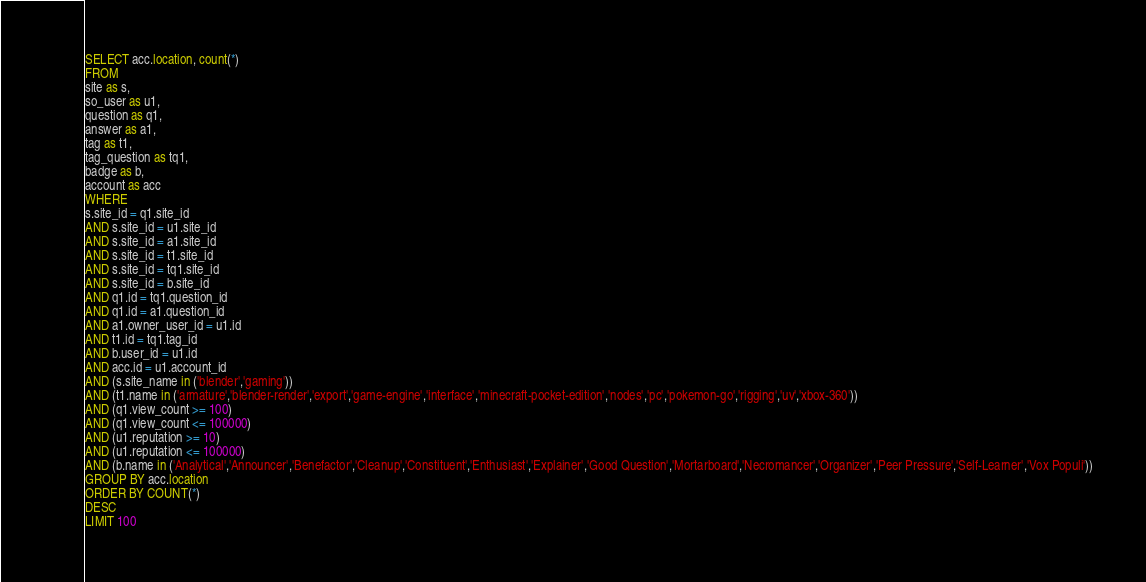Convert code to text. <code><loc_0><loc_0><loc_500><loc_500><_SQL_>SELECT acc.location, count(*)
FROM
site as s,
so_user as u1,
question as q1,
answer as a1,
tag as t1,
tag_question as tq1,
badge as b,
account as acc
WHERE
s.site_id = q1.site_id
AND s.site_id = u1.site_id
AND s.site_id = a1.site_id
AND s.site_id = t1.site_id
AND s.site_id = tq1.site_id
AND s.site_id = b.site_id
AND q1.id = tq1.question_id
AND q1.id = a1.question_id
AND a1.owner_user_id = u1.id
AND t1.id = tq1.tag_id
AND b.user_id = u1.id
AND acc.id = u1.account_id
AND (s.site_name in ('blender','gaming'))
AND (t1.name in ('armature','blender-render','export','game-engine','interface','minecraft-pocket-edition','nodes','pc','pokemon-go','rigging','uv','xbox-360'))
AND (q1.view_count >= 100)
AND (q1.view_count <= 100000)
AND (u1.reputation >= 10)
AND (u1.reputation <= 100000)
AND (b.name in ('Analytical','Announcer','Benefactor','Cleanup','Constituent','Enthusiast','Explainer','Good Question','Mortarboard','Necromancer','Organizer','Peer Pressure','Self-Learner','Vox Populi'))
GROUP BY acc.location
ORDER BY COUNT(*)
DESC
LIMIT 100
</code> 